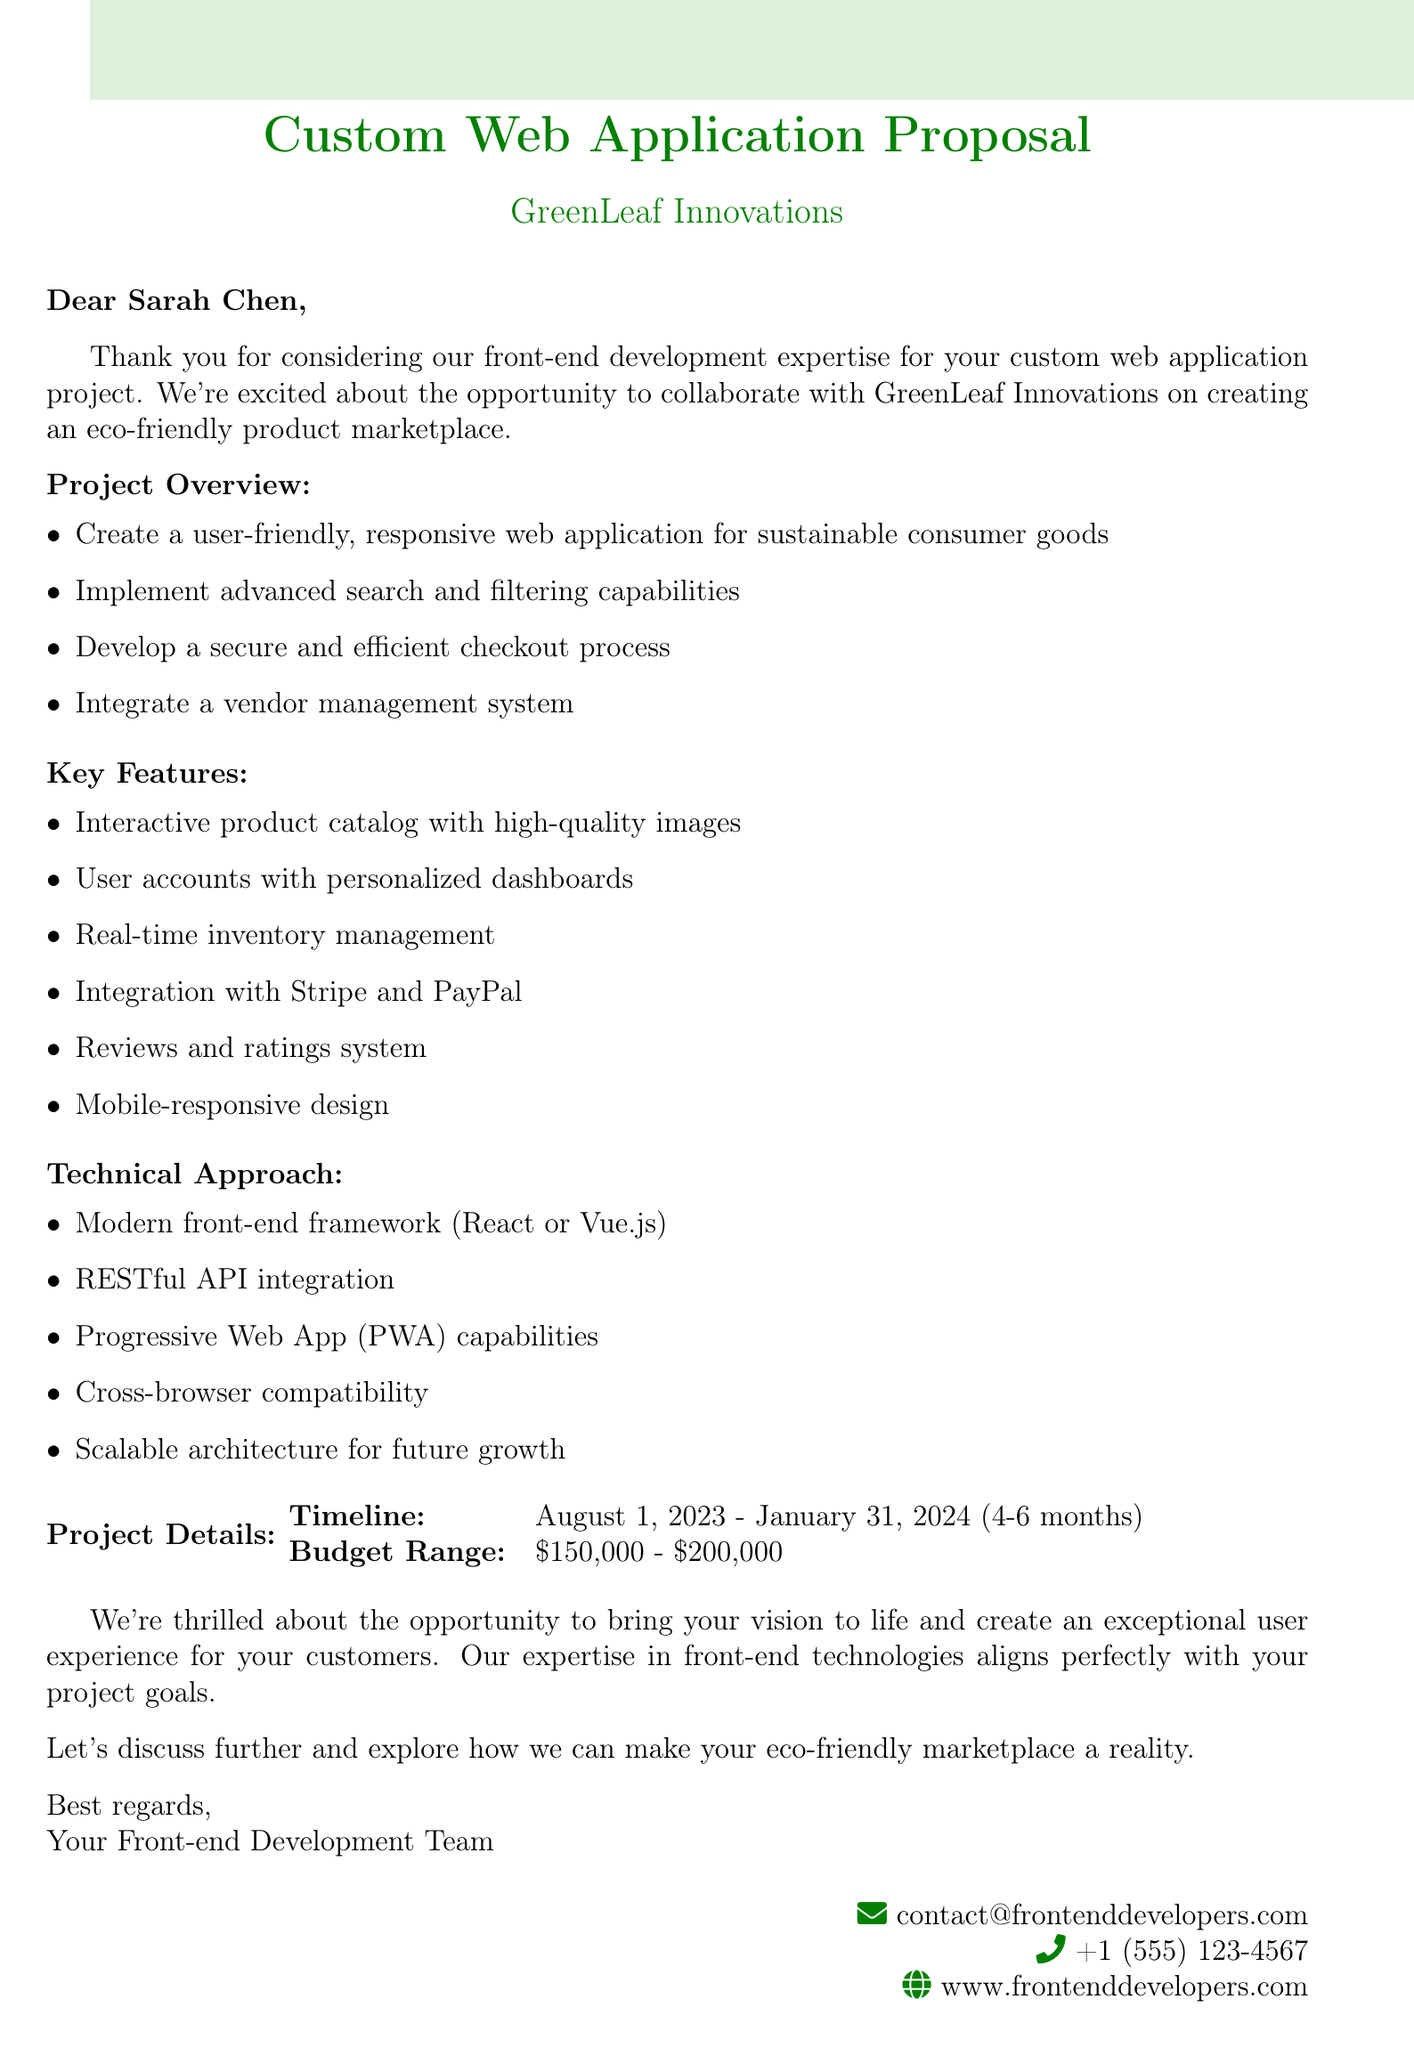What is the client company name? The client company name is explicitly stated in the document as "GreenLeaf Innovations."
Answer: GreenLeaf Innovations Who is the contact person for this project? The document specifies the contact person as "Sarah Chen."
Answer: Sarah Chen What is the desired start date for the project? The desired start date is mentioned in the timeline section of the document as "August 1, 2023."
Answer: August 1, 2023 What is the budget range for the project? The document provides the budget range as "$150,000 - $200,000."
Answer: $150,000 - $200,000 What key feature involves user experience improvements? The document states that "User accounts with personalized dashboards and order history" is a key feature focused on user experience.
Answer: User accounts with personalized dashboards and order history What technology is preferred for the front-end framework? The document mentions a preference for "React or Vue.js" as the modern front-end framework.
Answer: React or Vue.js How long is the expected project duration? The expected duration is referred to in the timeline section as "4-6 months."
Answer: 4-6 months What is the main goal of the collaboration? The document expresses excitement about bringing the client's "vision to life" and creating an exceptional user experience.
Answer: Bringing vision to life Which payment gateways are to be integrated? The document specifically lists "Stripe and PayPal" as the payment gateways for integration.
Answer: Stripe and PayPal 